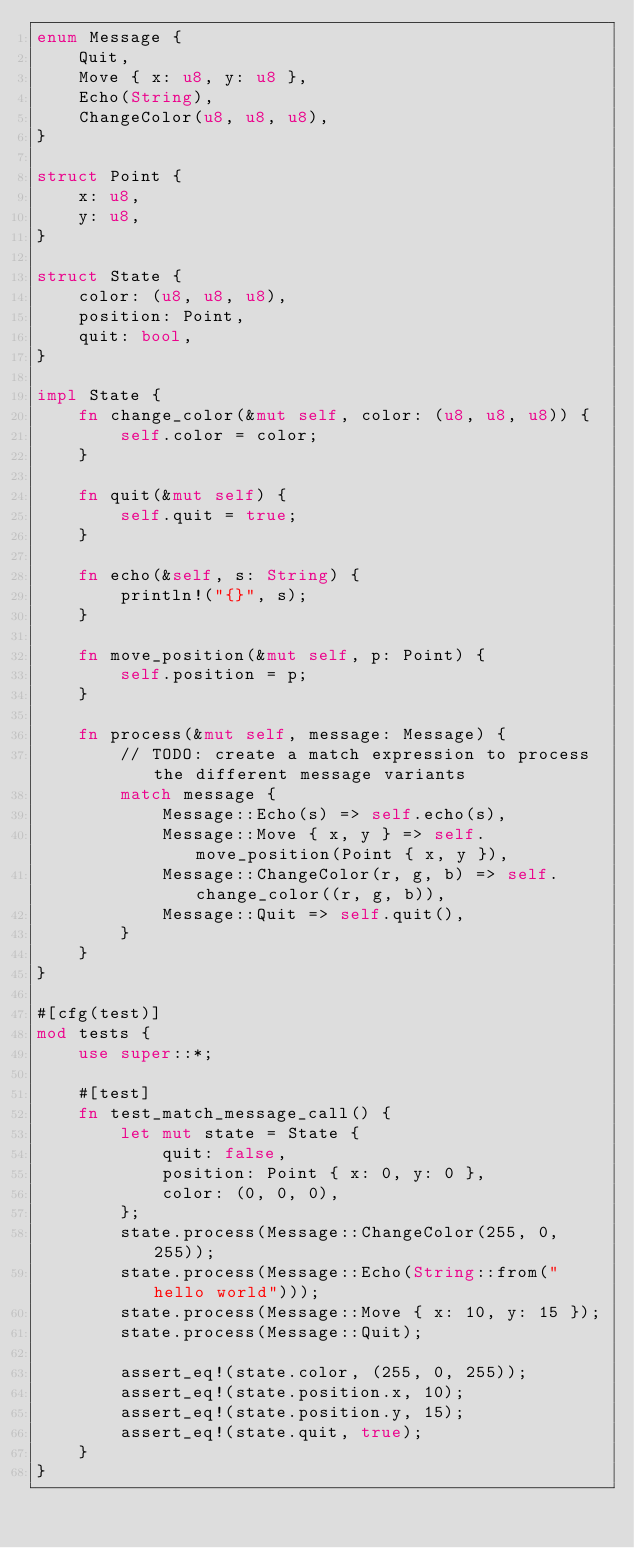Convert code to text. <code><loc_0><loc_0><loc_500><loc_500><_Rust_>enum Message {
    Quit,
    Move { x: u8, y: u8 },
    Echo(String),
    ChangeColor(u8, u8, u8),
}

struct Point {
    x: u8,
    y: u8,
}

struct State {
    color: (u8, u8, u8),
    position: Point,
    quit: bool,
}

impl State {
    fn change_color(&mut self, color: (u8, u8, u8)) {
        self.color = color;
    }

    fn quit(&mut self) {
        self.quit = true;
    }

    fn echo(&self, s: String) {
        println!("{}", s);
    }

    fn move_position(&mut self, p: Point) {
        self.position = p;
    }

    fn process(&mut self, message: Message) {
        // TODO: create a match expression to process the different message variants
        match message {
            Message::Echo(s) => self.echo(s),
            Message::Move { x, y } => self.move_position(Point { x, y }),
            Message::ChangeColor(r, g, b) => self.change_color((r, g, b)),
            Message::Quit => self.quit(),
        }
    }
}

#[cfg(test)]
mod tests {
    use super::*;

    #[test]
    fn test_match_message_call() {
        let mut state = State {
            quit: false,
            position: Point { x: 0, y: 0 },
            color: (0, 0, 0),
        };
        state.process(Message::ChangeColor(255, 0, 255));
        state.process(Message::Echo(String::from("hello world")));
        state.process(Message::Move { x: 10, y: 15 });
        state.process(Message::Quit);

        assert_eq!(state.color, (255, 0, 255));
        assert_eq!(state.position.x, 10);
        assert_eq!(state.position.y, 15);
        assert_eq!(state.quit, true);
    }
}
</code> 